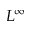<formula> <loc_0><loc_0><loc_500><loc_500>L ^ { \infty }</formula> 